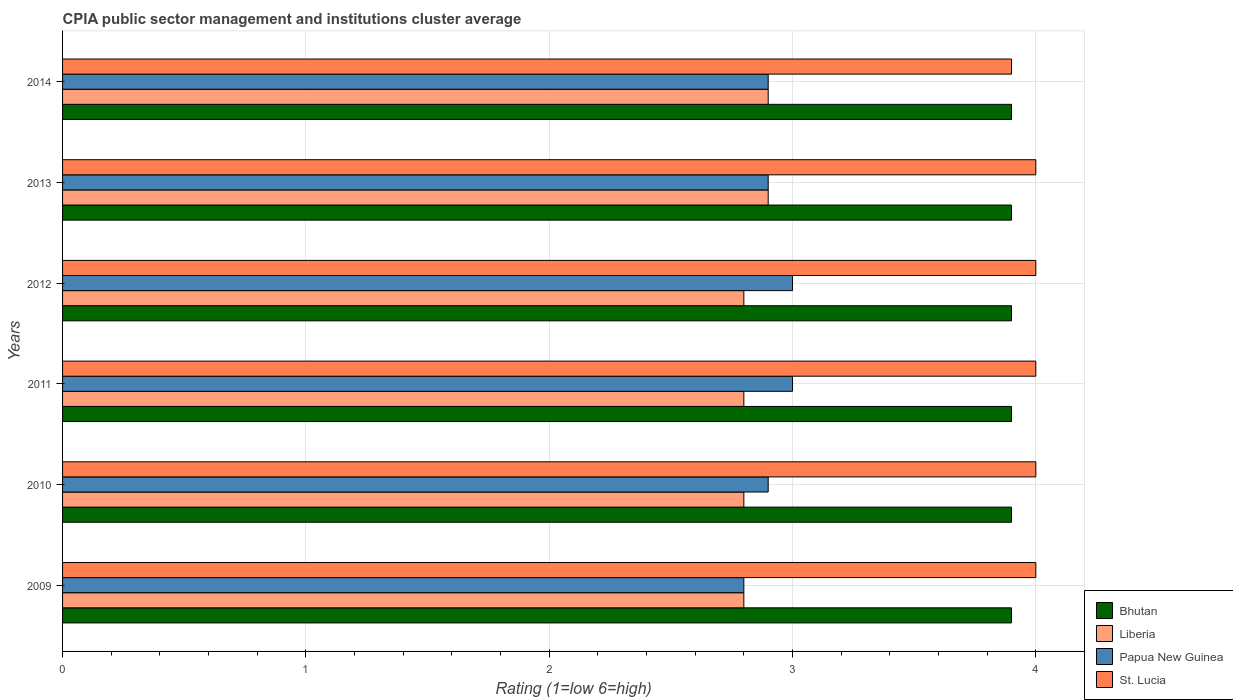How many bars are there on the 6th tick from the top?
Your response must be concise. 4. How many bars are there on the 2nd tick from the bottom?
Offer a terse response. 4. What is the CPIA rating in Bhutan in 2013?
Provide a succinct answer. 3.9. Across all years, what is the maximum CPIA rating in St. Lucia?
Your response must be concise. 4. Across all years, what is the minimum CPIA rating in Papua New Guinea?
Offer a very short reply. 2.8. In which year was the CPIA rating in Papua New Guinea maximum?
Offer a terse response. 2011. In which year was the CPIA rating in Bhutan minimum?
Provide a short and direct response. 2009. What is the total CPIA rating in St. Lucia in the graph?
Make the answer very short. 23.9. What is the difference between the CPIA rating in St. Lucia in 2011 and that in 2014?
Provide a succinct answer. 0.1. What is the difference between the CPIA rating in Bhutan in 2010 and the CPIA rating in St. Lucia in 2009?
Ensure brevity in your answer.  -0.1. In how many years, is the CPIA rating in Bhutan greater than 3.2 ?
Offer a terse response. 6. What is the ratio of the CPIA rating in Bhutan in 2012 to that in 2013?
Offer a very short reply. 1. What is the difference between the highest and the lowest CPIA rating in St. Lucia?
Your response must be concise. 0.1. In how many years, is the CPIA rating in Bhutan greater than the average CPIA rating in Bhutan taken over all years?
Your response must be concise. 0. Is it the case that in every year, the sum of the CPIA rating in Bhutan and CPIA rating in St. Lucia is greater than the sum of CPIA rating in Papua New Guinea and CPIA rating in Liberia?
Give a very brief answer. Yes. What does the 2nd bar from the top in 2011 represents?
Your answer should be compact. Papua New Guinea. What does the 2nd bar from the bottom in 2009 represents?
Provide a short and direct response. Liberia. Is it the case that in every year, the sum of the CPIA rating in Bhutan and CPIA rating in Papua New Guinea is greater than the CPIA rating in Liberia?
Your answer should be very brief. Yes. How many years are there in the graph?
Give a very brief answer. 6. Where does the legend appear in the graph?
Your answer should be compact. Bottom right. How many legend labels are there?
Make the answer very short. 4. What is the title of the graph?
Provide a short and direct response. CPIA public sector management and institutions cluster average. What is the label or title of the Y-axis?
Ensure brevity in your answer.  Years. What is the Rating (1=low 6=high) in Bhutan in 2009?
Keep it short and to the point. 3.9. What is the Rating (1=low 6=high) in Liberia in 2009?
Provide a short and direct response. 2.8. What is the Rating (1=low 6=high) in Papua New Guinea in 2009?
Your response must be concise. 2.8. What is the Rating (1=low 6=high) of Liberia in 2011?
Provide a short and direct response. 2.8. What is the Rating (1=low 6=high) of Bhutan in 2014?
Offer a very short reply. 3.9. What is the Rating (1=low 6=high) of Liberia in 2014?
Your answer should be very brief. 2.9. What is the Rating (1=low 6=high) in Papua New Guinea in 2014?
Offer a terse response. 2.9. What is the Rating (1=low 6=high) in St. Lucia in 2014?
Your answer should be compact. 3.9. Across all years, what is the maximum Rating (1=low 6=high) of Bhutan?
Give a very brief answer. 3.9. Across all years, what is the maximum Rating (1=low 6=high) in Liberia?
Give a very brief answer. 2.9. Across all years, what is the maximum Rating (1=low 6=high) of St. Lucia?
Provide a succinct answer. 4. Across all years, what is the minimum Rating (1=low 6=high) of Bhutan?
Your answer should be very brief. 3.9. Across all years, what is the minimum Rating (1=low 6=high) of Liberia?
Provide a short and direct response. 2.8. What is the total Rating (1=low 6=high) of Bhutan in the graph?
Ensure brevity in your answer.  23.4. What is the total Rating (1=low 6=high) in Liberia in the graph?
Your answer should be very brief. 17. What is the total Rating (1=low 6=high) of St. Lucia in the graph?
Make the answer very short. 23.9. What is the difference between the Rating (1=low 6=high) in Bhutan in 2009 and that in 2011?
Make the answer very short. 0. What is the difference between the Rating (1=low 6=high) of Liberia in 2009 and that in 2011?
Keep it short and to the point. 0. What is the difference between the Rating (1=low 6=high) in Bhutan in 2009 and that in 2012?
Keep it short and to the point. 0. What is the difference between the Rating (1=low 6=high) in Liberia in 2009 and that in 2012?
Your response must be concise. 0. What is the difference between the Rating (1=low 6=high) in Bhutan in 2009 and that in 2013?
Provide a short and direct response. 0. What is the difference between the Rating (1=low 6=high) of Papua New Guinea in 2009 and that in 2013?
Keep it short and to the point. -0.1. What is the difference between the Rating (1=low 6=high) of Bhutan in 2009 and that in 2014?
Your response must be concise. 0. What is the difference between the Rating (1=low 6=high) of Liberia in 2009 and that in 2014?
Give a very brief answer. -0.1. What is the difference between the Rating (1=low 6=high) in St. Lucia in 2009 and that in 2014?
Keep it short and to the point. 0.1. What is the difference between the Rating (1=low 6=high) of Liberia in 2010 and that in 2011?
Make the answer very short. 0. What is the difference between the Rating (1=low 6=high) of Papua New Guinea in 2010 and that in 2011?
Your response must be concise. -0.1. What is the difference between the Rating (1=low 6=high) of St. Lucia in 2010 and that in 2011?
Ensure brevity in your answer.  0. What is the difference between the Rating (1=low 6=high) of Bhutan in 2010 and that in 2012?
Offer a terse response. 0. What is the difference between the Rating (1=low 6=high) in St. Lucia in 2010 and that in 2012?
Your answer should be compact. 0. What is the difference between the Rating (1=low 6=high) of Bhutan in 2010 and that in 2013?
Keep it short and to the point. 0. What is the difference between the Rating (1=low 6=high) in Liberia in 2010 and that in 2013?
Offer a very short reply. -0.1. What is the difference between the Rating (1=low 6=high) in Liberia in 2010 and that in 2014?
Make the answer very short. -0.1. What is the difference between the Rating (1=low 6=high) of Papua New Guinea in 2010 and that in 2014?
Offer a very short reply. 0. What is the difference between the Rating (1=low 6=high) of Liberia in 2011 and that in 2012?
Your answer should be compact. 0. What is the difference between the Rating (1=low 6=high) in Papua New Guinea in 2011 and that in 2012?
Ensure brevity in your answer.  0. What is the difference between the Rating (1=low 6=high) of Bhutan in 2011 and that in 2013?
Offer a terse response. 0. What is the difference between the Rating (1=low 6=high) of Bhutan in 2011 and that in 2014?
Give a very brief answer. 0. What is the difference between the Rating (1=low 6=high) of Liberia in 2011 and that in 2014?
Your answer should be very brief. -0.1. What is the difference between the Rating (1=low 6=high) of Papua New Guinea in 2011 and that in 2014?
Provide a succinct answer. 0.1. What is the difference between the Rating (1=low 6=high) of Bhutan in 2012 and that in 2013?
Provide a short and direct response. 0. What is the difference between the Rating (1=low 6=high) of Liberia in 2012 and that in 2013?
Provide a short and direct response. -0.1. What is the difference between the Rating (1=low 6=high) of Liberia in 2012 and that in 2014?
Provide a short and direct response. -0.1. What is the difference between the Rating (1=low 6=high) in Bhutan in 2013 and that in 2014?
Offer a very short reply. 0. What is the difference between the Rating (1=low 6=high) of Bhutan in 2009 and the Rating (1=low 6=high) of Papua New Guinea in 2010?
Make the answer very short. 1. What is the difference between the Rating (1=low 6=high) of Bhutan in 2009 and the Rating (1=low 6=high) of St. Lucia in 2010?
Your answer should be compact. -0.1. What is the difference between the Rating (1=low 6=high) of Liberia in 2009 and the Rating (1=low 6=high) of Papua New Guinea in 2010?
Ensure brevity in your answer.  -0.1. What is the difference between the Rating (1=low 6=high) in Papua New Guinea in 2009 and the Rating (1=low 6=high) in St. Lucia in 2010?
Give a very brief answer. -1.2. What is the difference between the Rating (1=low 6=high) in Bhutan in 2009 and the Rating (1=low 6=high) in Papua New Guinea in 2011?
Provide a succinct answer. 0.9. What is the difference between the Rating (1=low 6=high) in Bhutan in 2009 and the Rating (1=low 6=high) in St. Lucia in 2011?
Offer a very short reply. -0.1. What is the difference between the Rating (1=low 6=high) in Liberia in 2009 and the Rating (1=low 6=high) in Papua New Guinea in 2011?
Your answer should be compact. -0.2. What is the difference between the Rating (1=low 6=high) of Liberia in 2009 and the Rating (1=low 6=high) of St. Lucia in 2011?
Keep it short and to the point. -1.2. What is the difference between the Rating (1=low 6=high) of Bhutan in 2009 and the Rating (1=low 6=high) of Papua New Guinea in 2012?
Your answer should be very brief. 0.9. What is the difference between the Rating (1=low 6=high) in Papua New Guinea in 2009 and the Rating (1=low 6=high) in St. Lucia in 2012?
Keep it short and to the point. -1.2. What is the difference between the Rating (1=low 6=high) in Bhutan in 2009 and the Rating (1=low 6=high) in St. Lucia in 2013?
Give a very brief answer. -0.1. What is the difference between the Rating (1=low 6=high) in Liberia in 2009 and the Rating (1=low 6=high) in Papua New Guinea in 2013?
Offer a very short reply. -0.1. What is the difference between the Rating (1=low 6=high) in Liberia in 2009 and the Rating (1=low 6=high) in St. Lucia in 2013?
Keep it short and to the point. -1.2. What is the difference between the Rating (1=low 6=high) in Papua New Guinea in 2009 and the Rating (1=low 6=high) in St. Lucia in 2013?
Keep it short and to the point. -1.2. What is the difference between the Rating (1=low 6=high) in Bhutan in 2009 and the Rating (1=low 6=high) in Papua New Guinea in 2014?
Offer a very short reply. 1. What is the difference between the Rating (1=low 6=high) of Bhutan in 2010 and the Rating (1=low 6=high) of Papua New Guinea in 2011?
Give a very brief answer. 0.9. What is the difference between the Rating (1=low 6=high) of Bhutan in 2010 and the Rating (1=low 6=high) of St. Lucia in 2011?
Your response must be concise. -0.1. What is the difference between the Rating (1=low 6=high) in Liberia in 2010 and the Rating (1=low 6=high) in St. Lucia in 2011?
Your answer should be compact. -1.2. What is the difference between the Rating (1=low 6=high) in Papua New Guinea in 2010 and the Rating (1=low 6=high) in St. Lucia in 2011?
Make the answer very short. -1.1. What is the difference between the Rating (1=low 6=high) in Bhutan in 2010 and the Rating (1=low 6=high) in Liberia in 2012?
Your response must be concise. 1.1. What is the difference between the Rating (1=low 6=high) in Bhutan in 2010 and the Rating (1=low 6=high) in Papua New Guinea in 2012?
Give a very brief answer. 0.9. What is the difference between the Rating (1=low 6=high) in Liberia in 2010 and the Rating (1=low 6=high) in Papua New Guinea in 2012?
Your response must be concise. -0.2. What is the difference between the Rating (1=low 6=high) of Bhutan in 2010 and the Rating (1=low 6=high) of St. Lucia in 2013?
Your answer should be compact. -0.1. What is the difference between the Rating (1=low 6=high) of Liberia in 2010 and the Rating (1=low 6=high) of Papua New Guinea in 2013?
Your answer should be very brief. -0.1. What is the difference between the Rating (1=low 6=high) of Papua New Guinea in 2010 and the Rating (1=low 6=high) of St. Lucia in 2013?
Offer a terse response. -1.1. What is the difference between the Rating (1=low 6=high) of Bhutan in 2010 and the Rating (1=low 6=high) of Papua New Guinea in 2014?
Provide a short and direct response. 1. What is the difference between the Rating (1=low 6=high) in Papua New Guinea in 2010 and the Rating (1=low 6=high) in St. Lucia in 2014?
Ensure brevity in your answer.  -1. What is the difference between the Rating (1=low 6=high) of Bhutan in 2011 and the Rating (1=low 6=high) of Liberia in 2012?
Offer a terse response. 1.1. What is the difference between the Rating (1=low 6=high) of Bhutan in 2011 and the Rating (1=low 6=high) of Papua New Guinea in 2012?
Give a very brief answer. 0.9. What is the difference between the Rating (1=low 6=high) in Bhutan in 2011 and the Rating (1=low 6=high) in St. Lucia in 2012?
Ensure brevity in your answer.  -0.1. What is the difference between the Rating (1=low 6=high) of Papua New Guinea in 2011 and the Rating (1=low 6=high) of St. Lucia in 2012?
Offer a very short reply. -1. What is the difference between the Rating (1=low 6=high) of Bhutan in 2011 and the Rating (1=low 6=high) of St. Lucia in 2013?
Offer a very short reply. -0.1. What is the difference between the Rating (1=low 6=high) in Papua New Guinea in 2011 and the Rating (1=low 6=high) in St. Lucia in 2013?
Provide a short and direct response. -1. What is the difference between the Rating (1=low 6=high) of Bhutan in 2011 and the Rating (1=low 6=high) of Liberia in 2014?
Your answer should be very brief. 1. What is the difference between the Rating (1=low 6=high) in Liberia in 2011 and the Rating (1=low 6=high) in Papua New Guinea in 2014?
Offer a terse response. -0.1. What is the difference between the Rating (1=low 6=high) in Papua New Guinea in 2011 and the Rating (1=low 6=high) in St. Lucia in 2014?
Make the answer very short. -0.9. What is the difference between the Rating (1=low 6=high) in Bhutan in 2012 and the Rating (1=low 6=high) in Papua New Guinea in 2013?
Give a very brief answer. 1. What is the difference between the Rating (1=low 6=high) of Bhutan in 2012 and the Rating (1=low 6=high) of St. Lucia in 2013?
Your answer should be very brief. -0.1. What is the difference between the Rating (1=low 6=high) of Liberia in 2012 and the Rating (1=low 6=high) of Papua New Guinea in 2013?
Keep it short and to the point. -0.1. What is the difference between the Rating (1=low 6=high) of Papua New Guinea in 2012 and the Rating (1=low 6=high) of St. Lucia in 2013?
Ensure brevity in your answer.  -1. What is the difference between the Rating (1=low 6=high) of Bhutan in 2012 and the Rating (1=low 6=high) of Papua New Guinea in 2014?
Provide a succinct answer. 1. What is the difference between the Rating (1=low 6=high) of Bhutan in 2012 and the Rating (1=low 6=high) of St. Lucia in 2014?
Keep it short and to the point. 0. What is the difference between the Rating (1=low 6=high) of Liberia in 2012 and the Rating (1=low 6=high) of Papua New Guinea in 2014?
Keep it short and to the point. -0.1. What is the difference between the Rating (1=low 6=high) in Liberia in 2013 and the Rating (1=low 6=high) in St. Lucia in 2014?
Your answer should be very brief. -1. What is the average Rating (1=low 6=high) in Bhutan per year?
Make the answer very short. 3.9. What is the average Rating (1=low 6=high) of Liberia per year?
Keep it short and to the point. 2.83. What is the average Rating (1=low 6=high) in Papua New Guinea per year?
Keep it short and to the point. 2.92. What is the average Rating (1=low 6=high) of St. Lucia per year?
Your answer should be compact. 3.98. In the year 2009, what is the difference between the Rating (1=low 6=high) of Bhutan and Rating (1=low 6=high) of Liberia?
Provide a succinct answer. 1.1. In the year 2010, what is the difference between the Rating (1=low 6=high) of Liberia and Rating (1=low 6=high) of Papua New Guinea?
Give a very brief answer. -0.1. In the year 2010, what is the difference between the Rating (1=low 6=high) of Liberia and Rating (1=low 6=high) of St. Lucia?
Make the answer very short. -1.2. In the year 2010, what is the difference between the Rating (1=low 6=high) of Papua New Guinea and Rating (1=low 6=high) of St. Lucia?
Your answer should be compact. -1.1. In the year 2011, what is the difference between the Rating (1=low 6=high) in Bhutan and Rating (1=low 6=high) in Liberia?
Give a very brief answer. 1.1. In the year 2011, what is the difference between the Rating (1=low 6=high) in Liberia and Rating (1=low 6=high) in St. Lucia?
Offer a very short reply. -1.2. In the year 2011, what is the difference between the Rating (1=low 6=high) of Papua New Guinea and Rating (1=low 6=high) of St. Lucia?
Give a very brief answer. -1. In the year 2012, what is the difference between the Rating (1=low 6=high) in Bhutan and Rating (1=low 6=high) in Liberia?
Your response must be concise. 1.1. In the year 2012, what is the difference between the Rating (1=low 6=high) of Bhutan and Rating (1=low 6=high) of Papua New Guinea?
Offer a very short reply. 0.9. In the year 2012, what is the difference between the Rating (1=low 6=high) in Bhutan and Rating (1=low 6=high) in St. Lucia?
Provide a short and direct response. -0.1. In the year 2012, what is the difference between the Rating (1=low 6=high) of Liberia and Rating (1=low 6=high) of Papua New Guinea?
Provide a short and direct response. -0.2. In the year 2012, what is the difference between the Rating (1=low 6=high) in Papua New Guinea and Rating (1=low 6=high) in St. Lucia?
Offer a very short reply. -1. In the year 2013, what is the difference between the Rating (1=low 6=high) in Bhutan and Rating (1=low 6=high) in Papua New Guinea?
Ensure brevity in your answer.  1. In the year 2013, what is the difference between the Rating (1=low 6=high) of Liberia and Rating (1=low 6=high) of Papua New Guinea?
Keep it short and to the point. 0. In the year 2014, what is the difference between the Rating (1=low 6=high) of Liberia and Rating (1=low 6=high) of Papua New Guinea?
Make the answer very short. 0. What is the ratio of the Rating (1=low 6=high) of Papua New Guinea in 2009 to that in 2010?
Keep it short and to the point. 0.97. What is the ratio of the Rating (1=low 6=high) of Bhutan in 2009 to that in 2012?
Provide a succinct answer. 1. What is the ratio of the Rating (1=low 6=high) of Liberia in 2009 to that in 2012?
Make the answer very short. 1. What is the ratio of the Rating (1=low 6=high) of Papua New Guinea in 2009 to that in 2012?
Provide a succinct answer. 0.93. What is the ratio of the Rating (1=low 6=high) of Liberia in 2009 to that in 2013?
Make the answer very short. 0.97. What is the ratio of the Rating (1=low 6=high) of Papua New Guinea in 2009 to that in 2013?
Offer a terse response. 0.97. What is the ratio of the Rating (1=low 6=high) in St. Lucia in 2009 to that in 2013?
Your response must be concise. 1. What is the ratio of the Rating (1=low 6=high) of Liberia in 2009 to that in 2014?
Provide a succinct answer. 0.97. What is the ratio of the Rating (1=low 6=high) in Papua New Guinea in 2009 to that in 2014?
Make the answer very short. 0.97. What is the ratio of the Rating (1=low 6=high) of St. Lucia in 2009 to that in 2014?
Provide a short and direct response. 1.03. What is the ratio of the Rating (1=low 6=high) in Liberia in 2010 to that in 2011?
Keep it short and to the point. 1. What is the ratio of the Rating (1=low 6=high) of Papua New Guinea in 2010 to that in 2011?
Offer a very short reply. 0.97. What is the ratio of the Rating (1=low 6=high) in Liberia in 2010 to that in 2012?
Provide a short and direct response. 1. What is the ratio of the Rating (1=low 6=high) in Papua New Guinea in 2010 to that in 2012?
Your answer should be compact. 0.97. What is the ratio of the Rating (1=low 6=high) in Bhutan in 2010 to that in 2013?
Offer a very short reply. 1. What is the ratio of the Rating (1=low 6=high) in Liberia in 2010 to that in 2013?
Your answer should be compact. 0.97. What is the ratio of the Rating (1=low 6=high) of Papua New Guinea in 2010 to that in 2013?
Provide a short and direct response. 1. What is the ratio of the Rating (1=low 6=high) of Liberia in 2010 to that in 2014?
Offer a terse response. 0.97. What is the ratio of the Rating (1=low 6=high) of St. Lucia in 2010 to that in 2014?
Offer a terse response. 1.03. What is the ratio of the Rating (1=low 6=high) of St. Lucia in 2011 to that in 2012?
Your answer should be very brief. 1. What is the ratio of the Rating (1=low 6=high) in Bhutan in 2011 to that in 2013?
Keep it short and to the point. 1. What is the ratio of the Rating (1=low 6=high) of Liberia in 2011 to that in 2013?
Give a very brief answer. 0.97. What is the ratio of the Rating (1=low 6=high) of Papua New Guinea in 2011 to that in 2013?
Provide a succinct answer. 1.03. What is the ratio of the Rating (1=low 6=high) in Liberia in 2011 to that in 2014?
Keep it short and to the point. 0.97. What is the ratio of the Rating (1=low 6=high) of Papua New Guinea in 2011 to that in 2014?
Offer a terse response. 1.03. What is the ratio of the Rating (1=low 6=high) in St. Lucia in 2011 to that in 2014?
Offer a terse response. 1.03. What is the ratio of the Rating (1=low 6=high) of Liberia in 2012 to that in 2013?
Give a very brief answer. 0.97. What is the ratio of the Rating (1=low 6=high) in Papua New Guinea in 2012 to that in 2013?
Make the answer very short. 1.03. What is the ratio of the Rating (1=low 6=high) in St. Lucia in 2012 to that in 2013?
Offer a very short reply. 1. What is the ratio of the Rating (1=low 6=high) of Liberia in 2012 to that in 2014?
Provide a succinct answer. 0.97. What is the ratio of the Rating (1=low 6=high) of Papua New Guinea in 2012 to that in 2014?
Provide a succinct answer. 1.03. What is the ratio of the Rating (1=low 6=high) of St. Lucia in 2012 to that in 2014?
Keep it short and to the point. 1.03. What is the ratio of the Rating (1=low 6=high) of Papua New Guinea in 2013 to that in 2014?
Offer a very short reply. 1. What is the ratio of the Rating (1=low 6=high) in St. Lucia in 2013 to that in 2014?
Give a very brief answer. 1.03. What is the difference between the highest and the second highest Rating (1=low 6=high) of Bhutan?
Your answer should be compact. 0. What is the difference between the highest and the second highest Rating (1=low 6=high) in Papua New Guinea?
Ensure brevity in your answer.  0. What is the difference between the highest and the lowest Rating (1=low 6=high) in Bhutan?
Your response must be concise. 0. What is the difference between the highest and the lowest Rating (1=low 6=high) in Liberia?
Make the answer very short. 0.1. What is the difference between the highest and the lowest Rating (1=low 6=high) of Papua New Guinea?
Provide a short and direct response. 0.2. What is the difference between the highest and the lowest Rating (1=low 6=high) of St. Lucia?
Provide a succinct answer. 0.1. 